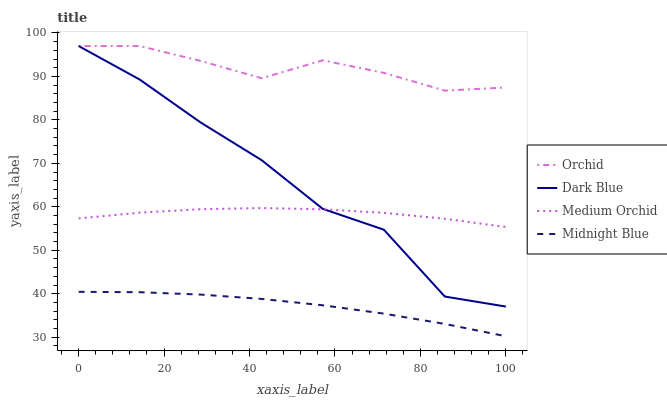Does Midnight Blue have the minimum area under the curve?
Answer yes or no. Yes. Does Orchid have the maximum area under the curve?
Answer yes or no. Yes. Does Medium Orchid have the minimum area under the curve?
Answer yes or no. No. Does Medium Orchid have the maximum area under the curve?
Answer yes or no. No. Is Midnight Blue the smoothest?
Answer yes or no. Yes. Is Dark Blue the roughest?
Answer yes or no. Yes. Is Medium Orchid the smoothest?
Answer yes or no. No. Is Medium Orchid the roughest?
Answer yes or no. No. Does Midnight Blue have the lowest value?
Answer yes or no. Yes. Does Medium Orchid have the lowest value?
Answer yes or no. No. Does Orchid have the highest value?
Answer yes or no. Yes. Does Medium Orchid have the highest value?
Answer yes or no. No. Is Midnight Blue less than Orchid?
Answer yes or no. Yes. Is Orchid greater than Medium Orchid?
Answer yes or no. Yes. Does Dark Blue intersect Medium Orchid?
Answer yes or no. Yes. Is Dark Blue less than Medium Orchid?
Answer yes or no. No. Is Dark Blue greater than Medium Orchid?
Answer yes or no. No. Does Midnight Blue intersect Orchid?
Answer yes or no. No. 